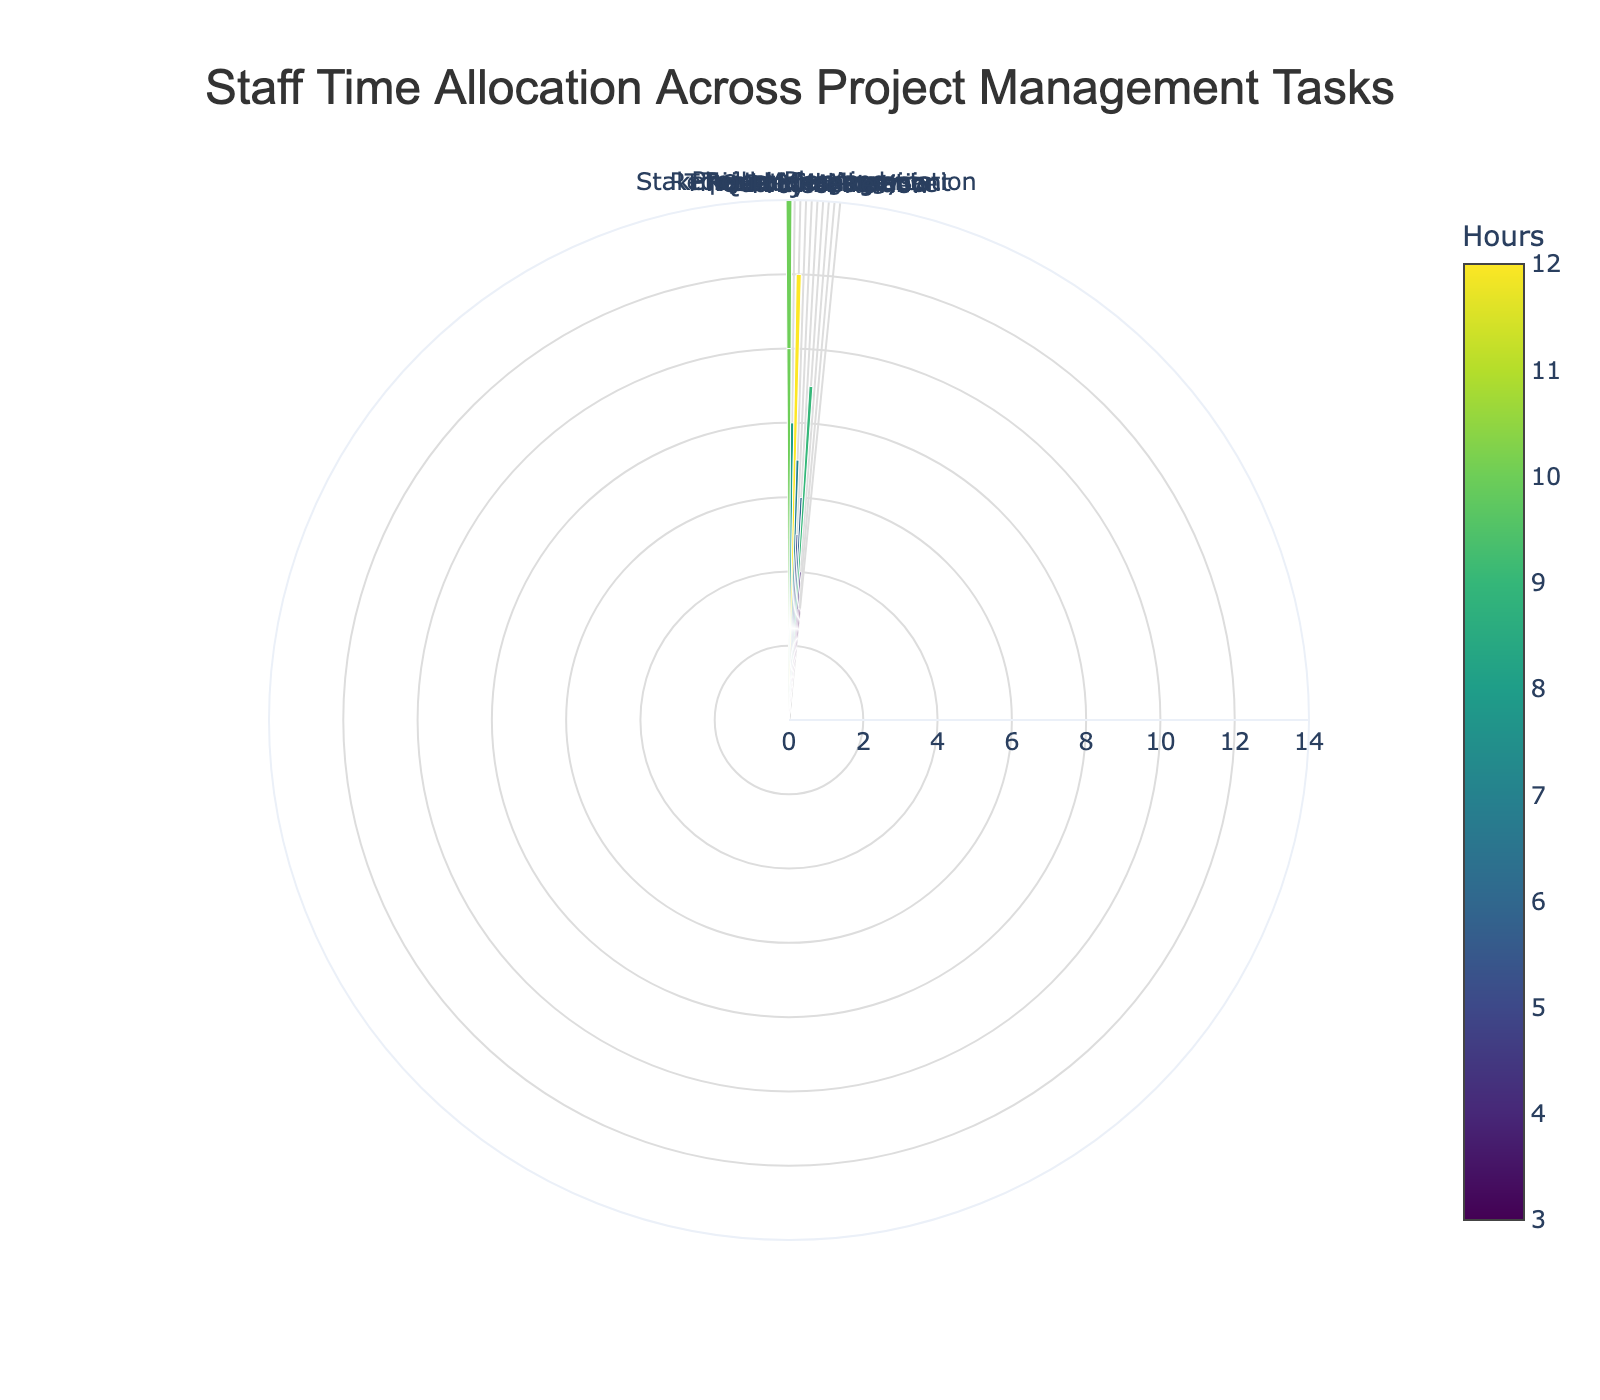What's the title of the figure? The title is usually displayed prominently at the top of the figure. In this figure, the title is positioned at the top and reads "Staff Time Allocation Across Project Management Tasks."
Answer: Staff Time Allocation Across Project Management Tasks How many project management tasks are displayed in the chart? The rose chart displays segments for each task, and the data lists each task, which can be counted. There are 10 tasks listed in the data.
Answer: 10 Which task has the highest allocation of hours? By looking at the length of the bars in the rose chart, the task with the longest bar has the highest allocation. "Requirement Analysis" has the longest bar with 12 hours.
Answer: Requirement Analysis How does "Quality Assurance" compare to "Team Meetings" in terms of hours? By comparing the bar lengths in the rose chart, "Quality Assurance" has a bar length of 4 hours whereas "Team Meetings" has a bar of 8 hours, so "Quality Assurance" has fewer hours than "Team Meetings."
Answer: Quality Assurance has fewer hours What is the total time spent on Stakeholder Communication and Resource Allocation combined? To find the total, we add the hours allocated for both tasks: Stakeholder Communication (7 hours) and Resource Allocation (9 hours), which totals to 7 + 9 = 16 hours.
Answer: 16 hours Which task takes up the least amount of staff time? By looking at the shortest bars in the rose chart, "Documentation" and "Project Review" each have the shortest bars with 3 hours.
Answer: Documentation and Project Review What percentage of the total time is dedicated to Project Planning? First, we calculate the total number of hours: 10 (Project Planning) + 8 (Team Meetings) + 12 (Requirement Analysis) + 7 (Stakeholder Communication) + 5 (Risk Management) + 6 (Timeline Management) + 9 (Resource Allocation) + 4 (Quality Assurance) + 3 (Documentation) + 3 (Project Review) = 67 hours. The percentage is then (10 / 67) * 100 ≈ 14.93%.
Answer: 14.93% How many hours more is spent on Requirement Analysis compared to Risk Management? Subtract the hours spent on Risk Management (5 hours) from the hours spent on Requirement Analysis (12 hours): 12 - 5 = 7 hours.
Answer: 7 hours Is the time spent on Risk Management more or less than the average time spent on all tasks? First, calculate the total hours: 67 hours. The number of tasks is 10, so the average time is 67 / 10 = 6.7 hours. The time spent on Risk Management is 5 hours, which is less than the average.
Answer: Less than the average What is the sum of hours allocated to Project Planning, Resource Allocation, and Documentation? To find the sum, add the hours: 10 (Project Planning) + 9 (Resource Allocation) + 3 (Documentation) = 22 hours.
Answer: 22 hours 